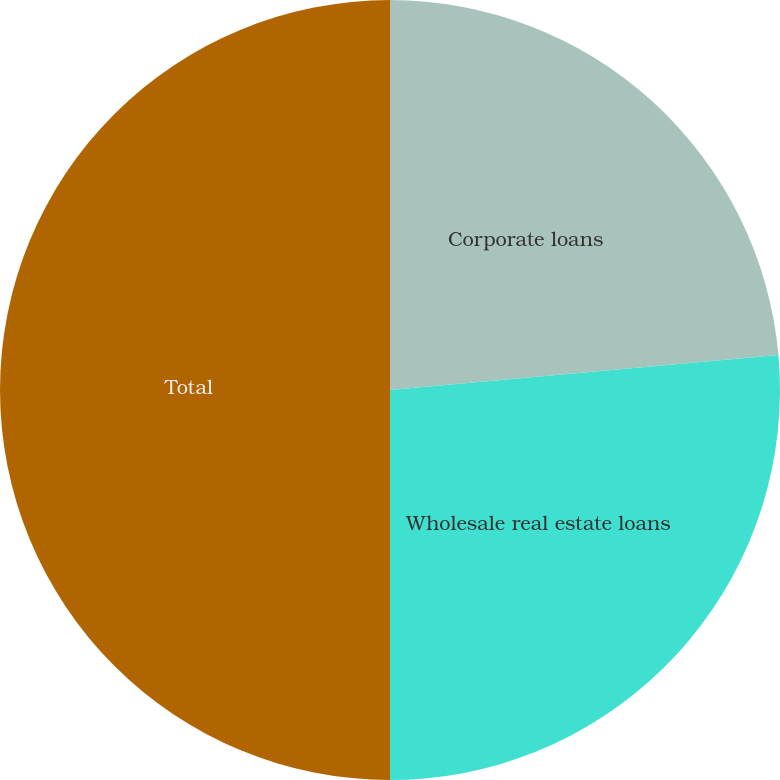<chart> <loc_0><loc_0><loc_500><loc_500><pie_chart><fcel>Corporate loans<fcel>Wholesale real estate loans<fcel>Total<nl><fcel>23.57%<fcel>26.43%<fcel>50.0%<nl></chart> 